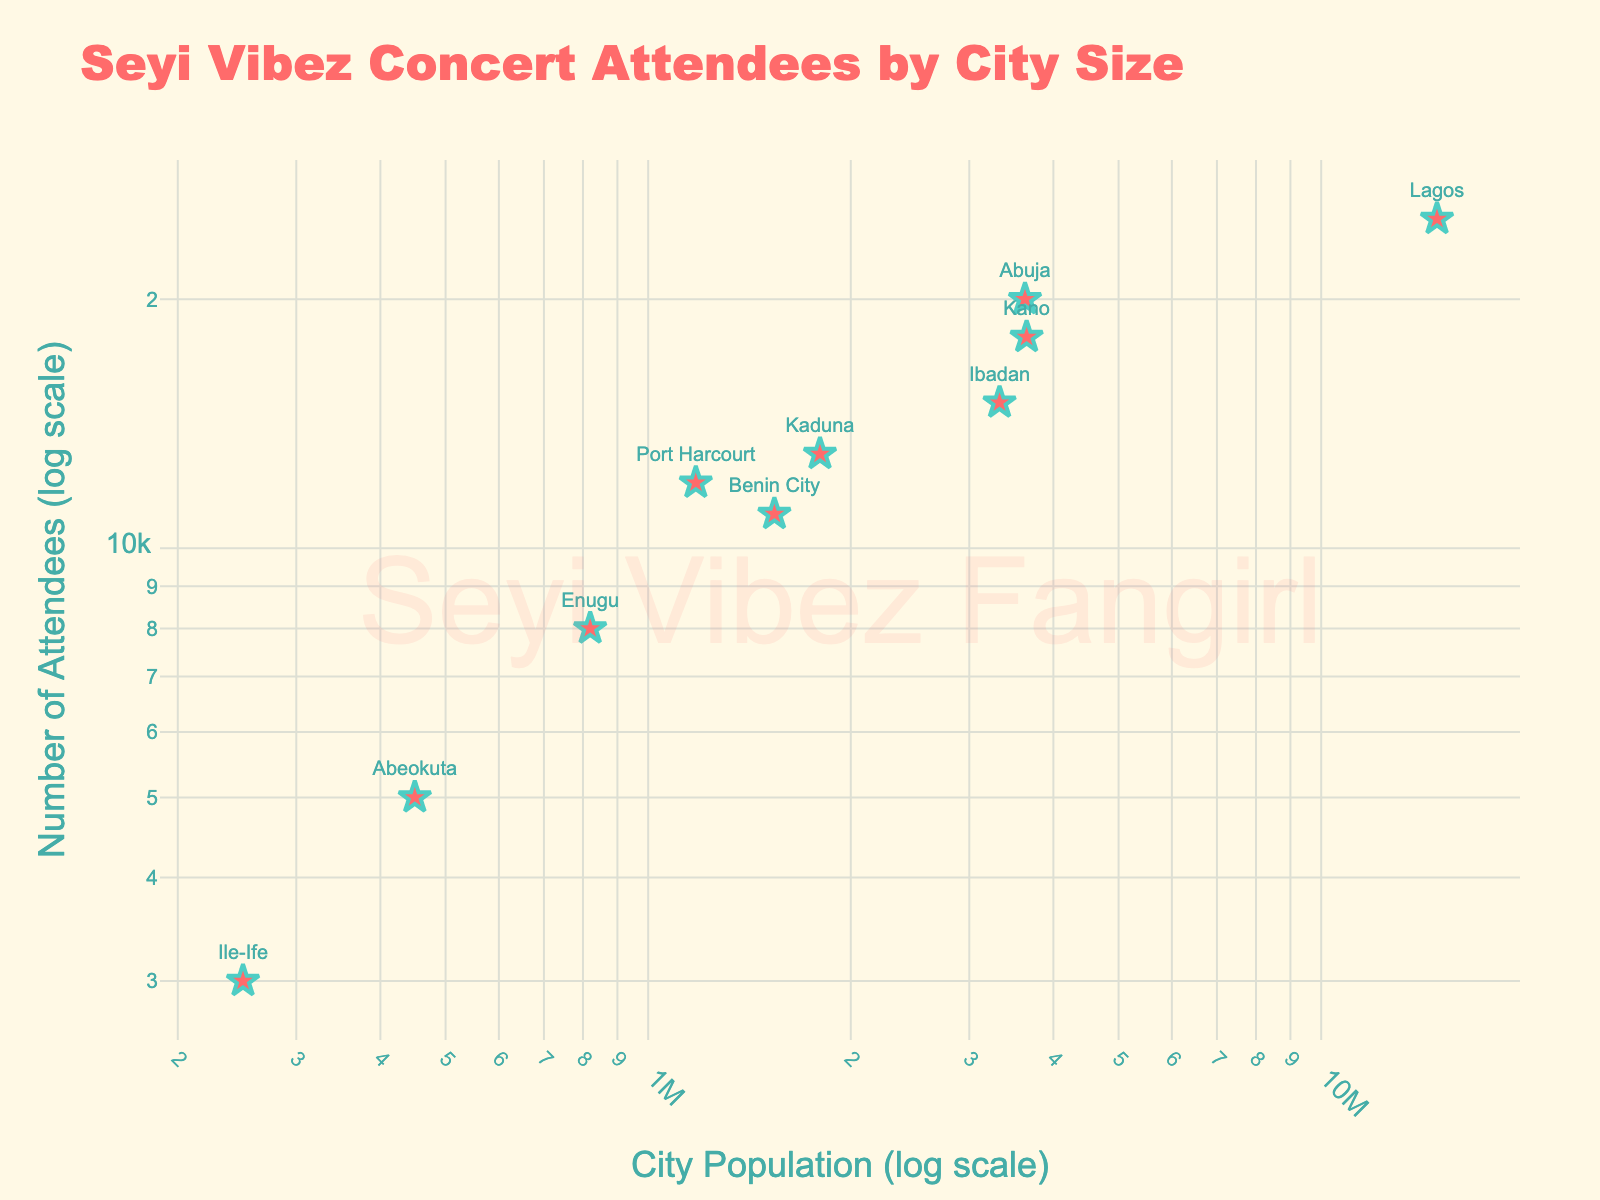What's the title of the scatter plot? The title of the scatter plot is at the top center of the figure. It summarizes what is being displayed in the visual.
Answer: Seyi Vibez Concert Attendees by City Size How many cities are represented in the scatter plot? Each marker on the scatter plot represents a city. By counting the markers, we can determine the number of cities.
Answer: 10 Which city has the highest number of concert attendees? By looking for the marker with the highest position on the y-axis (Number of Attendees), we can find the city with the highest number of concert attendees.
Answer: Lagos What's the relationship between city size and the number of concert attendees? Observe the overall trend of the markers as city size (x-axis) increases to infer the relationship. The scatter plot uses a log scale on both axes.
Answer: Generally, larger cities have more concert attendees Which city has the smallest size but more than 5,000 attendees? Identify the markers with more than 5,000 attendees on the y-axis and then find the one with the smallest value on the x-axis (City Size).
Answer: Enugu What is the city size and number of concert attendees for Abuja? Look for the marker labeled "Abuja" and note its position on both the x-axis and y-axis.
Answer: City Size: 3,630,000, Attendees: 20,000 How many cities have fewer than 10,000 concert attendees? Identify the markers that fall below the 10,000 attendees line on the y-axis, then count those markers.
Answer: 4 What is the approximate ratio of concert attendees between the largest and smallest cities? Divide the number of attendees in the largest city (Lagos) by that in the smallest city (Ile-Ife) to find the ratio.
Answer: Approximately 8.33 Compare the concert attendees in Kano and Port Harcourt. Which city had more attendees and by how much? Identify the marker positions for Kano and Port Harcourt on the y-axis, then subtract the smaller value (Port Harcourt) from the larger one (Kano).
Answer: Kano: 18,000, Port Harcourt: 12,000; Difference: 6,000 Which city has a similar number of concert attendees as Ibadan but a significantly different city size? Look for markers with similar y-axis positions (attendees) to Ibadan and then check their x-axis positions for city size differences.
Answer: Abuja 